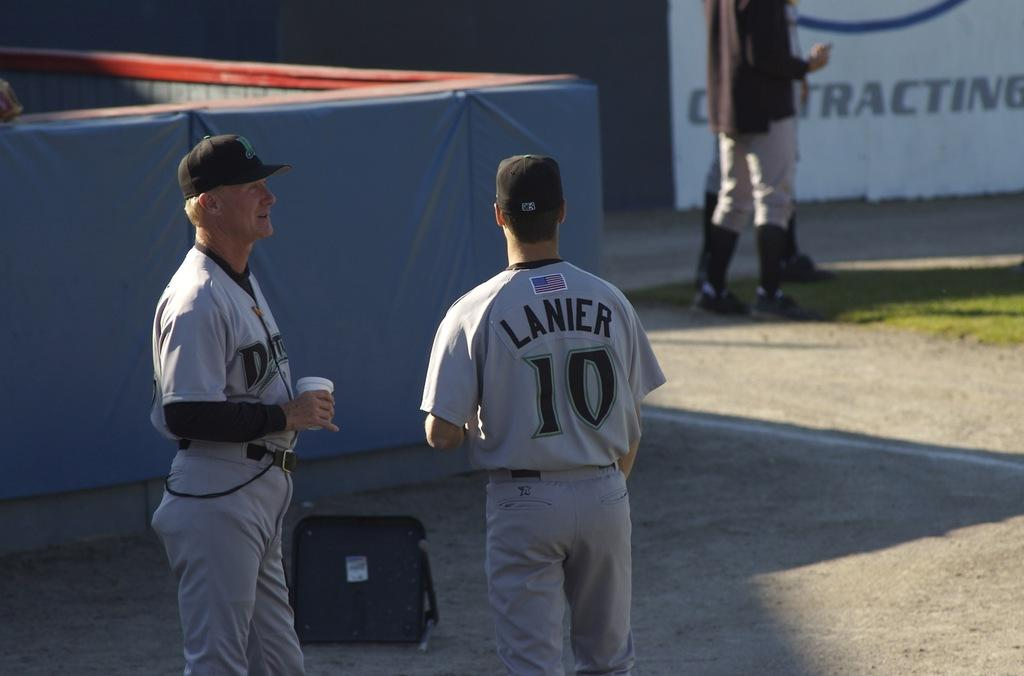<image>
Present a compact description of the photo's key features. Two baseball players are standing on the field with a jersey that says Lanier 10. 